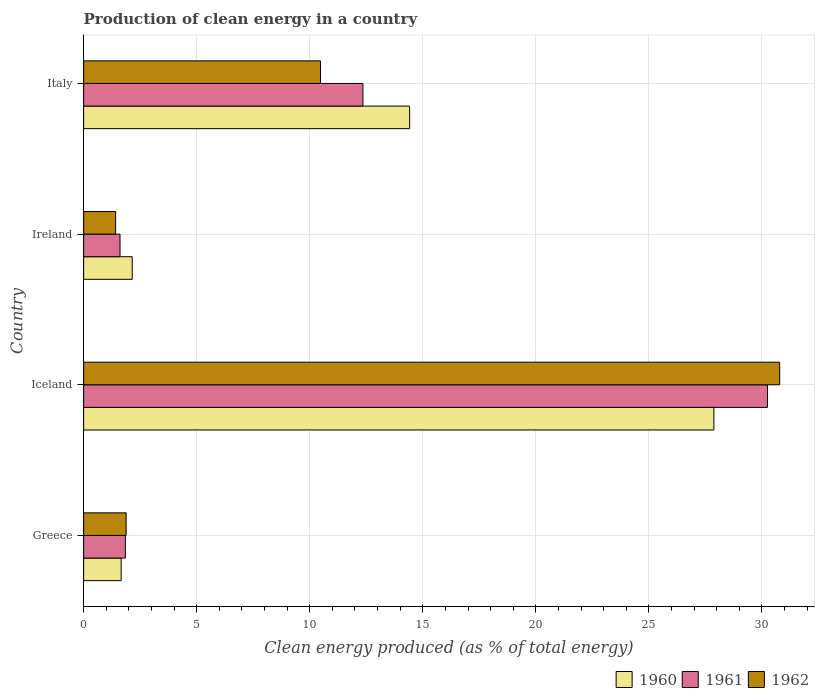Are the number of bars per tick equal to the number of legend labels?
Provide a short and direct response. Yes. Are the number of bars on each tick of the Y-axis equal?
Provide a short and direct response. Yes. How many bars are there on the 3rd tick from the top?
Provide a succinct answer. 3. What is the label of the 2nd group of bars from the top?
Make the answer very short. Ireland. What is the percentage of clean energy produced in 1961 in Ireland?
Make the answer very short. 1.61. Across all countries, what is the maximum percentage of clean energy produced in 1961?
Your answer should be very brief. 30.24. Across all countries, what is the minimum percentage of clean energy produced in 1961?
Offer a terse response. 1.61. What is the total percentage of clean energy produced in 1961 in the graph?
Offer a terse response. 46.05. What is the difference between the percentage of clean energy produced in 1962 in Iceland and that in Italy?
Your response must be concise. 20.31. What is the difference between the percentage of clean energy produced in 1961 in Italy and the percentage of clean energy produced in 1960 in Greece?
Provide a short and direct response. 10.69. What is the average percentage of clean energy produced in 1961 per country?
Keep it short and to the point. 11.51. What is the difference between the percentage of clean energy produced in 1960 and percentage of clean energy produced in 1961 in Italy?
Offer a very short reply. 2.07. In how many countries, is the percentage of clean energy produced in 1962 greater than 16 %?
Provide a succinct answer. 1. What is the ratio of the percentage of clean energy produced in 1960 in Greece to that in Ireland?
Offer a terse response. 0.77. Is the percentage of clean energy produced in 1961 in Iceland less than that in Ireland?
Your answer should be very brief. No. What is the difference between the highest and the second highest percentage of clean energy produced in 1961?
Your answer should be compact. 17.89. What is the difference between the highest and the lowest percentage of clean energy produced in 1960?
Ensure brevity in your answer.  26.21. In how many countries, is the percentage of clean energy produced in 1961 greater than the average percentage of clean energy produced in 1961 taken over all countries?
Provide a short and direct response. 2. What does the 2nd bar from the top in Greece represents?
Offer a terse response. 1961. How many bars are there?
Ensure brevity in your answer.  12. Are all the bars in the graph horizontal?
Keep it short and to the point. Yes. How many countries are there in the graph?
Ensure brevity in your answer.  4. Are the values on the major ticks of X-axis written in scientific E-notation?
Your response must be concise. No. Does the graph contain grids?
Make the answer very short. Yes. Where does the legend appear in the graph?
Make the answer very short. Bottom right. How many legend labels are there?
Keep it short and to the point. 3. How are the legend labels stacked?
Offer a terse response. Horizontal. What is the title of the graph?
Keep it short and to the point. Production of clean energy in a country. What is the label or title of the X-axis?
Provide a succinct answer. Clean energy produced (as % of total energy). What is the Clean energy produced (as % of total energy) of 1960 in Greece?
Offer a very short reply. 1.66. What is the Clean energy produced (as % of total energy) in 1961 in Greece?
Ensure brevity in your answer.  1.84. What is the Clean energy produced (as % of total energy) of 1962 in Greece?
Make the answer very short. 1.88. What is the Clean energy produced (as % of total energy) of 1960 in Iceland?
Give a very brief answer. 27.87. What is the Clean energy produced (as % of total energy) of 1961 in Iceland?
Provide a succinct answer. 30.24. What is the Clean energy produced (as % of total energy) of 1962 in Iceland?
Your response must be concise. 30.78. What is the Clean energy produced (as % of total energy) of 1960 in Ireland?
Make the answer very short. 2.15. What is the Clean energy produced (as % of total energy) in 1961 in Ireland?
Your answer should be compact. 1.61. What is the Clean energy produced (as % of total energy) in 1962 in Ireland?
Provide a succinct answer. 1.41. What is the Clean energy produced (as % of total energy) of 1960 in Italy?
Offer a terse response. 14.42. What is the Clean energy produced (as % of total energy) of 1961 in Italy?
Ensure brevity in your answer.  12.35. What is the Clean energy produced (as % of total energy) in 1962 in Italy?
Your answer should be compact. 10.48. Across all countries, what is the maximum Clean energy produced (as % of total energy) of 1960?
Offer a terse response. 27.87. Across all countries, what is the maximum Clean energy produced (as % of total energy) of 1961?
Give a very brief answer. 30.24. Across all countries, what is the maximum Clean energy produced (as % of total energy) of 1962?
Provide a succinct answer. 30.78. Across all countries, what is the minimum Clean energy produced (as % of total energy) in 1960?
Your answer should be compact. 1.66. Across all countries, what is the minimum Clean energy produced (as % of total energy) of 1961?
Provide a succinct answer. 1.61. Across all countries, what is the minimum Clean energy produced (as % of total energy) of 1962?
Provide a short and direct response. 1.41. What is the total Clean energy produced (as % of total energy) in 1960 in the graph?
Provide a succinct answer. 46.1. What is the total Clean energy produced (as % of total energy) in 1961 in the graph?
Your answer should be compact. 46.05. What is the total Clean energy produced (as % of total energy) of 1962 in the graph?
Your answer should be compact. 44.55. What is the difference between the Clean energy produced (as % of total energy) in 1960 in Greece and that in Iceland?
Ensure brevity in your answer.  -26.21. What is the difference between the Clean energy produced (as % of total energy) in 1961 in Greece and that in Iceland?
Give a very brief answer. -28.4. What is the difference between the Clean energy produced (as % of total energy) of 1962 in Greece and that in Iceland?
Your response must be concise. -28.9. What is the difference between the Clean energy produced (as % of total energy) in 1960 in Greece and that in Ireland?
Provide a succinct answer. -0.49. What is the difference between the Clean energy produced (as % of total energy) in 1961 in Greece and that in Ireland?
Give a very brief answer. 0.24. What is the difference between the Clean energy produced (as % of total energy) of 1962 in Greece and that in Ireland?
Offer a terse response. 0.46. What is the difference between the Clean energy produced (as % of total energy) of 1960 in Greece and that in Italy?
Ensure brevity in your answer.  -12.76. What is the difference between the Clean energy produced (as % of total energy) in 1961 in Greece and that in Italy?
Your answer should be compact. -10.51. What is the difference between the Clean energy produced (as % of total energy) of 1962 in Greece and that in Italy?
Your response must be concise. -8.6. What is the difference between the Clean energy produced (as % of total energy) of 1960 in Iceland and that in Ireland?
Give a very brief answer. 25.72. What is the difference between the Clean energy produced (as % of total energy) in 1961 in Iceland and that in Ireland?
Keep it short and to the point. 28.63. What is the difference between the Clean energy produced (as % of total energy) of 1962 in Iceland and that in Ireland?
Provide a short and direct response. 29.37. What is the difference between the Clean energy produced (as % of total energy) in 1960 in Iceland and that in Italy?
Your answer should be compact. 13.46. What is the difference between the Clean energy produced (as % of total energy) in 1961 in Iceland and that in Italy?
Provide a succinct answer. 17.89. What is the difference between the Clean energy produced (as % of total energy) in 1962 in Iceland and that in Italy?
Keep it short and to the point. 20.31. What is the difference between the Clean energy produced (as % of total energy) in 1960 in Ireland and that in Italy?
Provide a short and direct response. -12.27. What is the difference between the Clean energy produced (as % of total energy) of 1961 in Ireland and that in Italy?
Ensure brevity in your answer.  -10.74. What is the difference between the Clean energy produced (as % of total energy) of 1962 in Ireland and that in Italy?
Make the answer very short. -9.06. What is the difference between the Clean energy produced (as % of total energy) of 1960 in Greece and the Clean energy produced (as % of total energy) of 1961 in Iceland?
Provide a short and direct response. -28.58. What is the difference between the Clean energy produced (as % of total energy) in 1960 in Greece and the Clean energy produced (as % of total energy) in 1962 in Iceland?
Your answer should be compact. -29.12. What is the difference between the Clean energy produced (as % of total energy) of 1961 in Greece and the Clean energy produced (as % of total energy) of 1962 in Iceland?
Provide a short and direct response. -28.94. What is the difference between the Clean energy produced (as % of total energy) in 1960 in Greece and the Clean energy produced (as % of total energy) in 1961 in Ireland?
Keep it short and to the point. 0.05. What is the difference between the Clean energy produced (as % of total energy) in 1960 in Greece and the Clean energy produced (as % of total energy) in 1962 in Ireland?
Your answer should be very brief. 0.25. What is the difference between the Clean energy produced (as % of total energy) in 1961 in Greece and the Clean energy produced (as % of total energy) in 1962 in Ireland?
Offer a terse response. 0.43. What is the difference between the Clean energy produced (as % of total energy) of 1960 in Greece and the Clean energy produced (as % of total energy) of 1961 in Italy?
Make the answer very short. -10.69. What is the difference between the Clean energy produced (as % of total energy) in 1960 in Greece and the Clean energy produced (as % of total energy) in 1962 in Italy?
Provide a short and direct response. -8.82. What is the difference between the Clean energy produced (as % of total energy) of 1961 in Greece and the Clean energy produced (as % of total energy) of 1962 in Italy?
Keep it short and to the point. -8.63. What is the difference between the Clean energy produced (as % of total energy) of 1960 in Iceland and the Clean energy produced (as % of total energy) of 1961 in Ireland?
Offer a very short reply. 26.26. What is the difference between the Clean energy produced (as % of total energy) in 1960 in Iceland and the Clean energy produced (as % of total energy) in 1962 in Ireland?
Provide a succinct answer. 26.46. What is the difference between the Clean energy produced (as % of total energy) in 1961 in Iceland and the Clean energy produced (as % of total energy) in 1962 in Ireland?
Offer a terse response. 28.83. What is the difference between the Clean energy produced (as % of total energy) in 1960 in Iceland and the Clean energy produced (as % of total energy) in 1961 in Italy?
Your answer should be very brief. 15.52. What is the difference between the Clean energy produced (as % of total energy) in 1960 in Iceland and the Clean energy produced (as % of total energy) in 1962 in Italy?
Make the answer very short. 17.4. What is the difference between the Clean energy produced (as % of total energy) in 1961 in Iceland and the Clean energy produced (as % of total energy) in 1962 in Italy?
Your response must be concise. 19.77. What is the difference between the Clean energy produced (as % of total energy) of 1960 in Ireland and the Clean energy produced (as % of total energy) of 1961 in Italy?
Your answer should be very brief. -10.2. What is the difference between the Clean energy produced (as % of total energy) of 1960 in Ireland and the Clean energy produced (as % of total energy) of 1962 in Italy?
Offer a very short reply. -8.33. What is the difference between the Clean energy produced (as % of total energy) in 1961 in Ireland and the Clean energy produced (as % of total energy) in 1962 in Italy?
Your answer should be very brief. -8.87. What is the average Clean energy produced (as % of total energy) of 1960 per country?
Ensure brevity in your answer.  11.52. What is the average Clean energy produced (as % of total energy) of 1961 per country?
Offer a terse response. 11.51. What is the average Clean energy produced (as % of total energy) of 1962 per country?
Provide a succinct answer. 11.14. What is the difference between the Clean energy produced (as % of total energy) in 1960 and Clean energy produced (as % of total energy) in 1961 in Greece?
Your response must be concise. -0.18. What is the difference between the Clean energy produced (as % of total energy) of 1960 and Clean energy produced (as % of total energy) of 1962 in Greece?
Ensure brevity in your answer.  -0.22. What is the difference between the Clean energy produced (as % of total energy) in 1961 and Clean energy produced (as % of total energy) in 1962 in Greece?
Offer a very short reply. -0.03. What is the difference between the Clean energy produced (as % of total energy) of 1960 and Clean energy produced (as % of total energy) of 1961 in Iceland?
Offer a terse response. -2.37. What is the difference between the Clean energy produced (as % of total energy) of 1960 and Clean energy produced (as % of total energy) of 1962 in Iceland?
Provide a short and direct response. -2.91. What is the difference between the Clean energy produced (as % of total energy) of 1961 and Clean energy produced (as % of total energy) of 1962 in Iceland?
Offer a very short reply. -0.54. What is the difference between the Clean energy produced (as % of total energy) of 1960 and Clean energy produced (as % of total energy) of 1961 in Ireland?
Offer a very short reply. 0.54. What is the difference between the Clean energy produced (as % of total energy) of 1960 and Clean energy produced (as % of total energy) of 1962 in Ireland?
Provide a short and direct response. 0.73. What is the difference between the Clean energy produced (as % of total energy) of 1961 and Clean energy produced (as % of total energy) of 1962 in Ireland?
Provide a succinct answer. 0.19. What is the difference between the Clean energy produced (as % of total energy) of 1960 and Clean energy produced (as % of total energy) of 1961 in Italy?
Your answer should be compact. 2.07. What is the difference between the Clean energy produced (as % of total energy) in 1960 and Clean energy produced (as % of total energy) in 1962 in Italy?
Keep it short and to the point. 3.94. What is the difference between the Clean energy produced (as % of total energy) of 1961 and Clean energy produced (as % of total energy) of 1962 in Italy?
Provide a succinct answer. 1.87. What is the ratio of the Clean energy produced (as % of total energy) in 1960 in Greece to that in Iceland?
Make the answer very short. 0.06. What is the ratio of the Clean energy produced (as % of total energy) of 1961 in Greece to that in Iceland?
Offer a terse response. 0.06. What is the ratio of the Clean energy produced (as % of total energy) of 1962 in Greece to that in Iceland?
Keep it short and to the point. 0.06. What is the ratio of the Clean energy produced (as % of total energy) in 1960 in Greece to that in Ireland?
Your response must be concise. 0.77. What is the ratio of the Clean energy produced (as % of total energy) of 1961 in Greece to that in Ireland?
Provide a succinct answer. 1.15. What is the ratio of the Clean energy produced (as % of total energy) in 1962 in Greece to that in Ireland?
Provide a succinct answer. 1.33. What is the ratio of the Clean energy produced (as % of total energy) of 1960 in Greece to that in Italy?
Offer a terse response. 0.12. What is the ratio of the Clean energy produced (as % of total energy) of 1961 in Greece to that in Italy?
Make the answer very short. 0.15. What is the ratio of the Clean energy produced (as % of total energy) in 1962 in Greece to that in Italy?
Offer a very short reply. 0.18. What is the ratio of the Clean energy produced (as % of total energy) of 1960 in Iceland to that in Ireland?
Give a very brief answer. 12.97. What is the ratio of the Clean energy produced (as % of total energy) in 1961 in Iceland to that in Ireland?
Give a very brief answer. 18.79. What is the ratio of the Clean energy produced (as % of total energy) in 1962 in Iceland to that in Ireland?
Ensure brevity in your answer.  21.76. What is the ratio of the Clean energy produced (as % of total energy) in 1960 in Iceland to that in Italy?
Your answer should be compact. 1.93. What is the ratio of the Clean energy produced (as % of total energy) in 1961 in Iceland to that in Italy?
Keep it short and to the point. 2.45. What is the ratio of the Clean energy produced (as % of total energy) of 1962 in Iceland to that in Italy?
Provide a short and direct response. 2.94. What is the ratio of the Clean energy produced (as % of total energy) of 1960 in Ireland to that in Italy?
Your answer should be compact. 0.15. What is the ratio of the Clean energy produced (as % of total energy) of 1961 in Ireland to that in Italy?
Provide a succinct answer. 0.13. What is the ratio of the Clean energy produced (as % of total energy) in 1962 in Ireland to that in Italy?
Provide a succinct answer. 0.14. What is the difference between the highest and the second highest Clean energy produced (as % of total energy) of 1960?
Provide a short and direct response. 13.46. What is the difference between the highest and the second highest Clean energy produced (as % of total energy) in 1961?
Your answer should be compact. 17.89. What is the difference between the highest and the second highest Clean energy produced (as % of total energy) of 1962?
Offer a very short reply. 20.31. What is the difference between the highest and the lowest Clean energy produced (as % of total energy) of 1960?
Offer a terse response. 26.21. What is the difference between the highest and the lowest Clean energy produced (as % of total energy) in 1961?
Give a very brief answer. 28.63. What is the difference between the highest and the lowest Clean energy produced (as % of total energy) of 1962?
Your answer should be very brief. 29.37. 